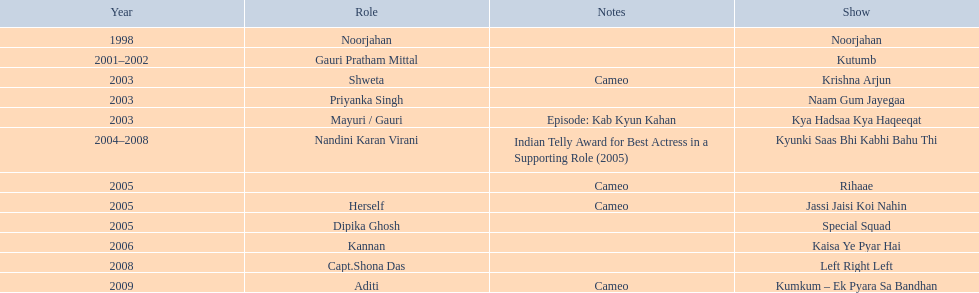How many shows are there? Noorjahan, Kutumb, Krishna Arjun, Naam Gum Jayegaa, Kya Hadsaa Kya Haqeeqat, Kyunki Saas Bhi Kabhi Bahu Thi, Rihaae, Jassi Jaisi Koi Nahin, Special Squad, Kaisa Ye Pyar Hai, Left Right Left, Kumkum – Ek Pyara Sa Bandhan. How many shows did she make a cameo appearance? Krishna Arjun, Rihaae, Jassi Jaisi Koi Nahin, Kumkum – Ek Pyara Sa Bandhan. Of those, how many did she play herself? Jassi Jaisi Koi Nahin. 